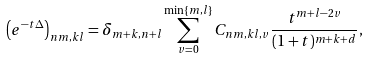<formula> <loc_0><loc_0><loc_500><loc_500>\left ( e ^ { - t { \Delta } } \right ) _ { n m , k l } = \delta _ { m + k , n + l } \sum _ { v = 0 } ^ { \min \{ m , l \} } C _ { n m , k l , v } \frac { t ^ { m + l - 2 v } } { ( 1 + t ) ^ { m + k + d } } ,</formula> 